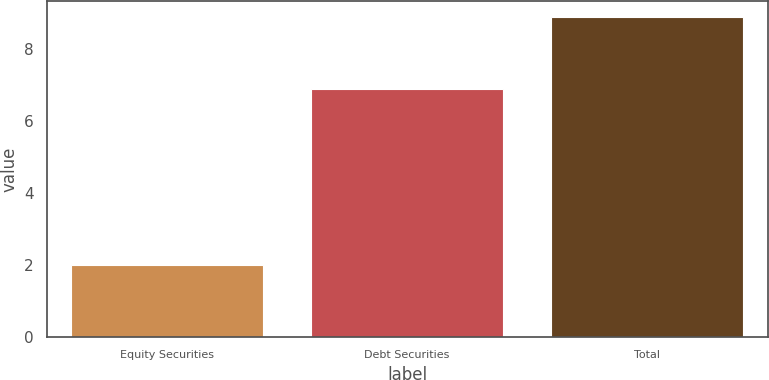<chart> <loc_0><loc_0><loc_500><loc_500><bar_chart><fcel>Equity Securities<fcel>Debt Securities<fcel>Total<nl><fcel>2<fcel>6.9<fcel>8.9<nl></chart> 